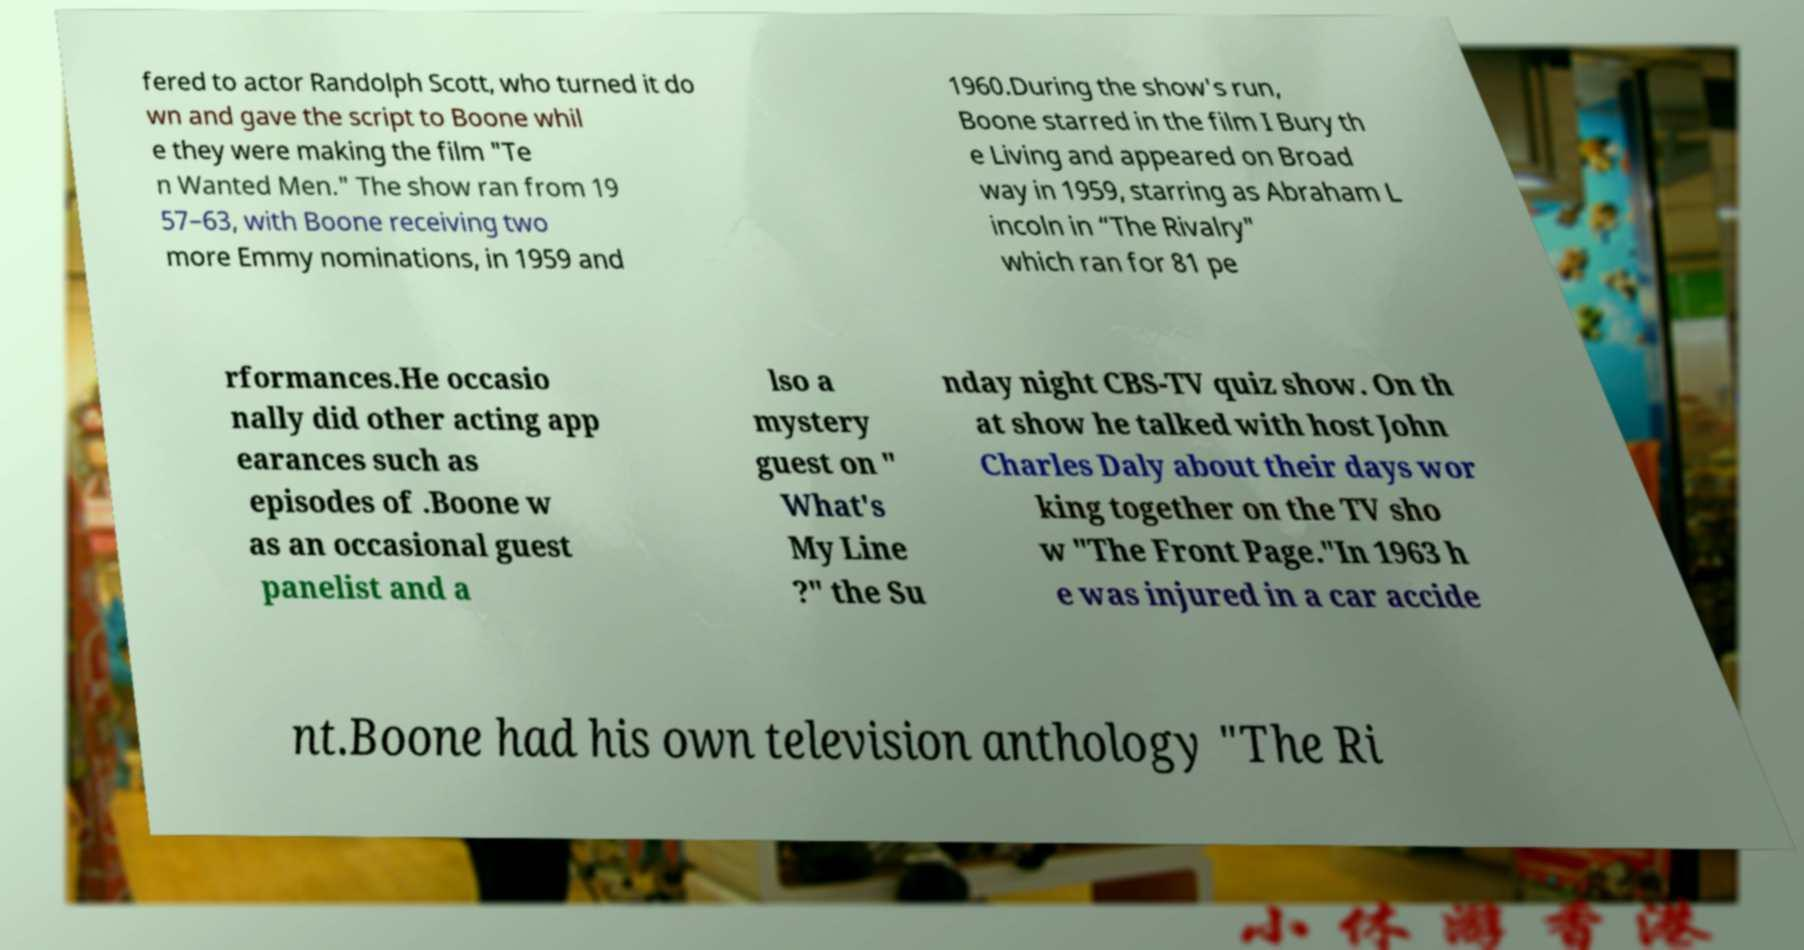For documentation purposes, I need the text within this image transcribed. Could you provide that? fered to actor Randolph Scott, who turned it do wn and gave the script to Boone whil e they were making the film "Te n Wanted Men." The show ran from 19 57–63, with Boone receiving two more Emmy nominations, in 1959 and 1960.During the show's run, Boone starred in the film I Bury th e Living and appeared on Broad way in 1959, starring as Abraham L incoln in “The Rivalry" which ran for 81 pe rformances.He occasio nally did other acting app earances such as episodes of .Boone w as an occasional guest panelist and a lso a mystery guest on " What's My Line ?" the Su nday night CBS-TV quiz show. On th at show he talked with host John Charles Daly about their days wor king together on the TV sho w "The Front Page."In 1963 h e was injured in a car accide nt.Boone had his own television anthology "The Ri 